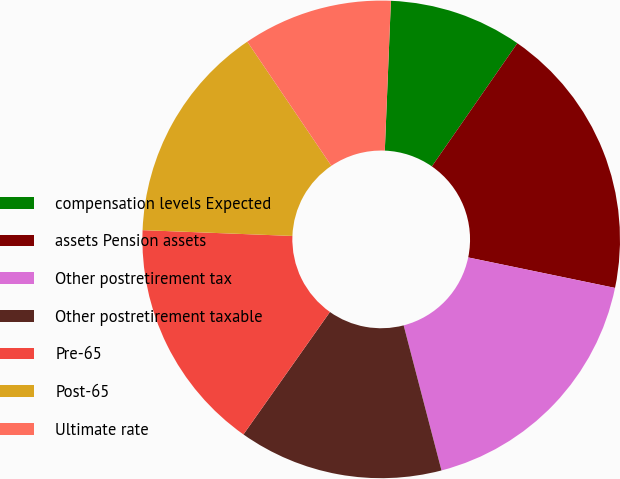Convert chart to OTSL. <chart><loc_0><loc_0><loc_500><loc_500><pie_chart><fcel>compensation levels Expected<fcel>assets Pension assets<fcel>Other postretirement tax<fcel>Other postretirement taxable<fcel>Pre-65<fcel>Post-65<fcel>Ultimate rate<nl><fcel>9.01%<fcel>18.6%<fcel>17.68%<fcel>13.85%<fcel>15.83%<fcel>14.91%<fcel>10.12%<nl></chart> 